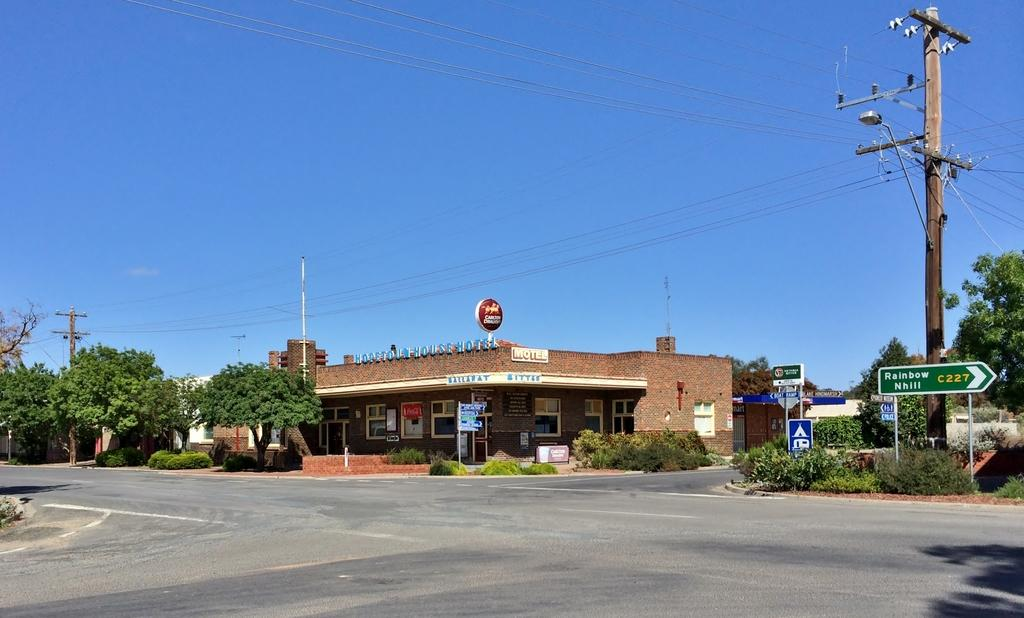What is the main feature of the image? There is a road in the image. What else can be seen along the road? There are boards on poles, plants, trees, and poles in the image. What else is present in the image? There are wires and a house in the background of the image. What can be seen in the sky? The sky is visible in the background of the image. Can you tell me how many experts are working on the stream in the image? There is no stream or experts present in the image. What type of wrench is being used by the expert in the image? There is no expert or wrench present in the image. 